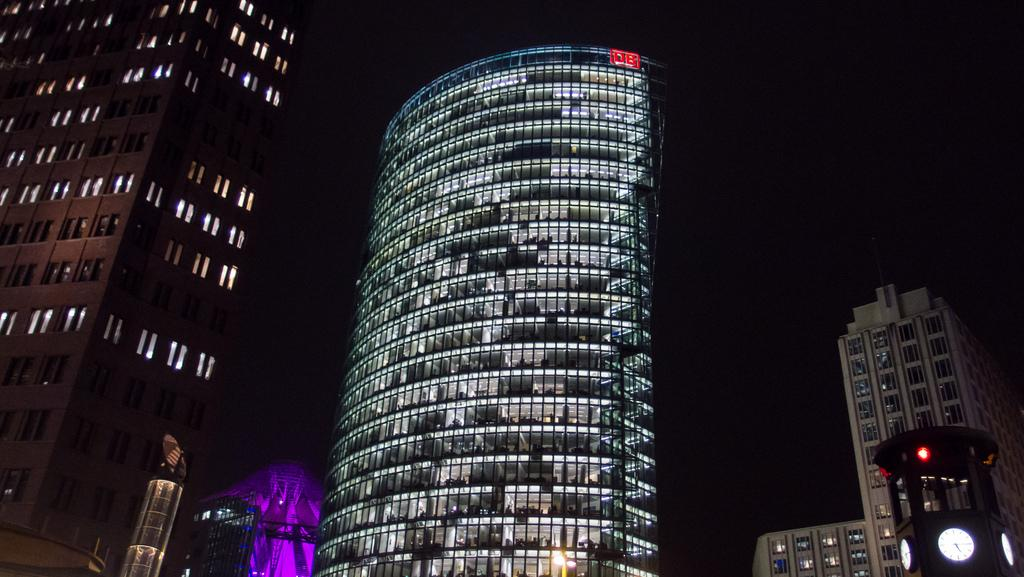What is the main subject in the foreground of the image? There is a clock tower in the foreground of the image. Where is the clock tower located in relation to the image? The clock tower is located in the right bottom corner. What can be seen in the background of the image? There are buildings and lights visible in the background. How would you describe the sky in the image? The sky appears dark in the image. How many cacti are growing on the clock tower in the image? There are no cacti present on the clock tower in the image. What causes the clock tower to burst in the image? There is no indication of the clock tower bursting in the image. 